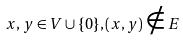<formula> <loc_0><loc_0><loc_500><loc_500>x , y \in V \cup \{ 0 \} , ( x , y ) \notin E</formula> 